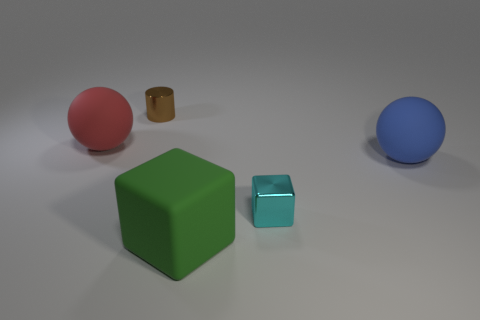Add 3 brown objects. How many objects exist? 8 Subtract all red balls. How many balls are left? 1 Subtract all spheres. How many objects are left? 3 Subtract 2 blocks. How many blocks are left? 0 Subtract all red balls. Subtract all red cubes. How many balls are left? 1 Subtract 1 cyan blocks. How many objects are left? 4 Subtract all cyan balls. How many green cylinders are left? 0 Subtract all red things. Subtract all brown shiny things. How many objects are left? 3 Add 2 big red spheres. How many big red spheres are left? 3 Add 3 small shiny cylinders. How many small shiny cylinders exist? 4 